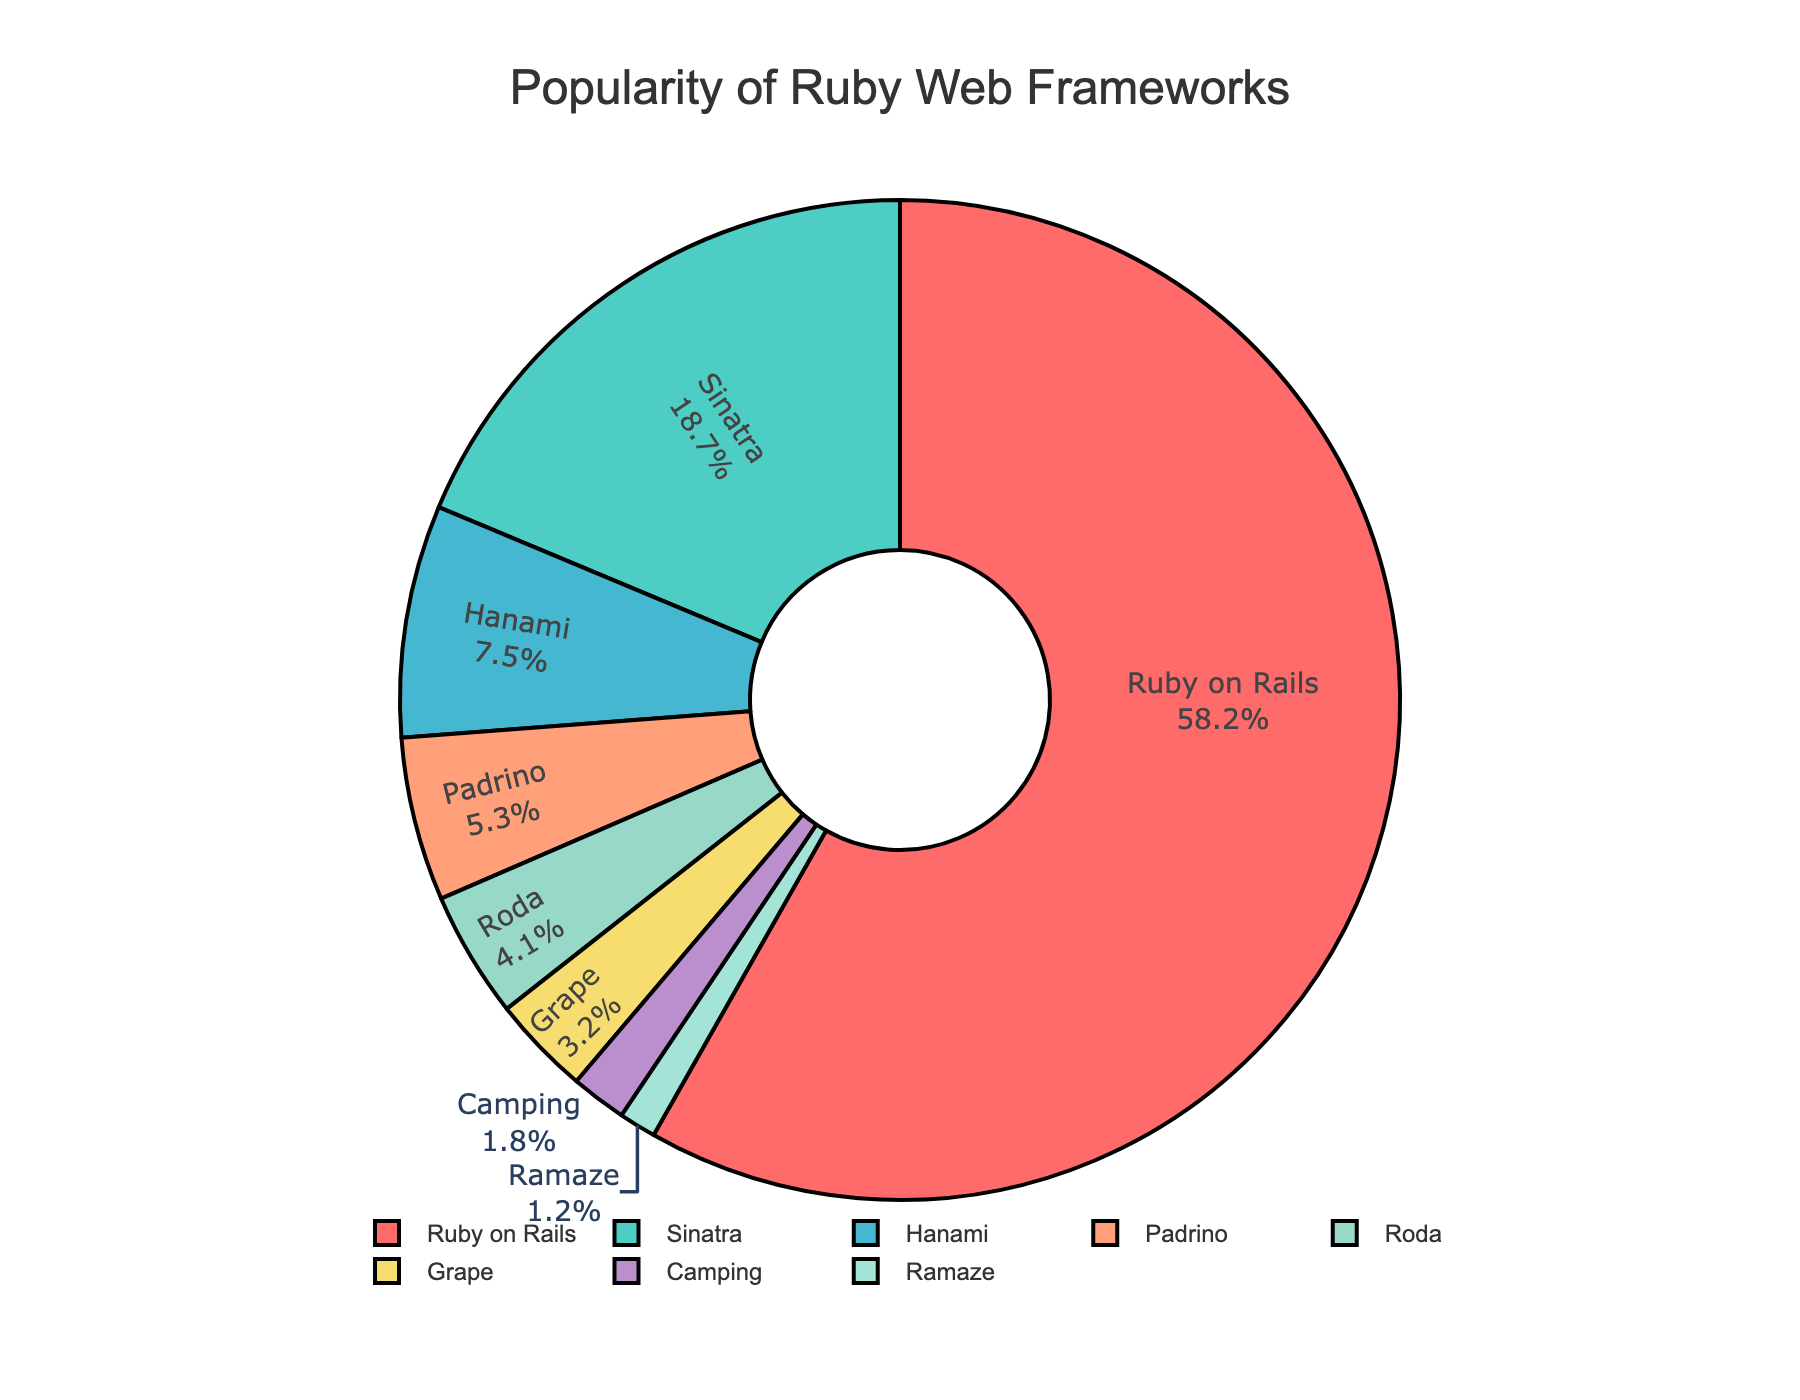Which framework has the highest popularity? The pie chart shows the percentage of popularity for each framework, and Ruby on Rails has the largest slice with 58.2%.
Answer: Ruby on Rails What is the combined popularity percentage of Sinatra and Hanami? Sinatra's popularity is 18.7% and Hanami's is 7.5%. Adding these together: 18.7 + 7.5 = 26.2%.
Answer: 26.2% How much more popular is Ruby on Rails compared to Sinatra? Ruby on Rails has 58.2% popularity and Sinatra has 18.7%. Subtracting the two: 58.2 - 18.7 = 39.5%.
Answer: 39.5% Which frameworks have a popularity less than 5%? The pie chart slices for Roda, Grape, Camping, and Ramaze all represent percentages lower than 5%.
Answer: Roda, Grape, Camping, Ramaze What is the average popularity percentage of Hanami, Padrino, and Roda? The percentages are 7.5% for Hanami, 5.3% for Padrino, and 4.1% for Roda. Adding them gives 7.5 + 5.3 + 4.1 = 16.9%. The average is 16.9 / 3 ≈ 5.63%.
Answer: 5.63% Is the percentage of Grape higher or lower than that of Padrino? The chart shows Padrino at 5.3% and Grape at 3.2%, so Grape's percentage is lower.
Answer: Lower Which framework has the least popularity? The smallest slice on the pie chart corresponds to Ramaze with 1.2% popularity.
Answer: Ramaze Are there more frameworks with popularity above 10% or below 10%? The frameworks above 10% popularity are Ruby on Rails (58.2%) and Sinatra (18.7%). Those below 10% are Hanami, Padrino, Roda, Grape, Camping, and Ramaze. There are 2 above 10% and 6 below 10%.
Answer: Below 10% 